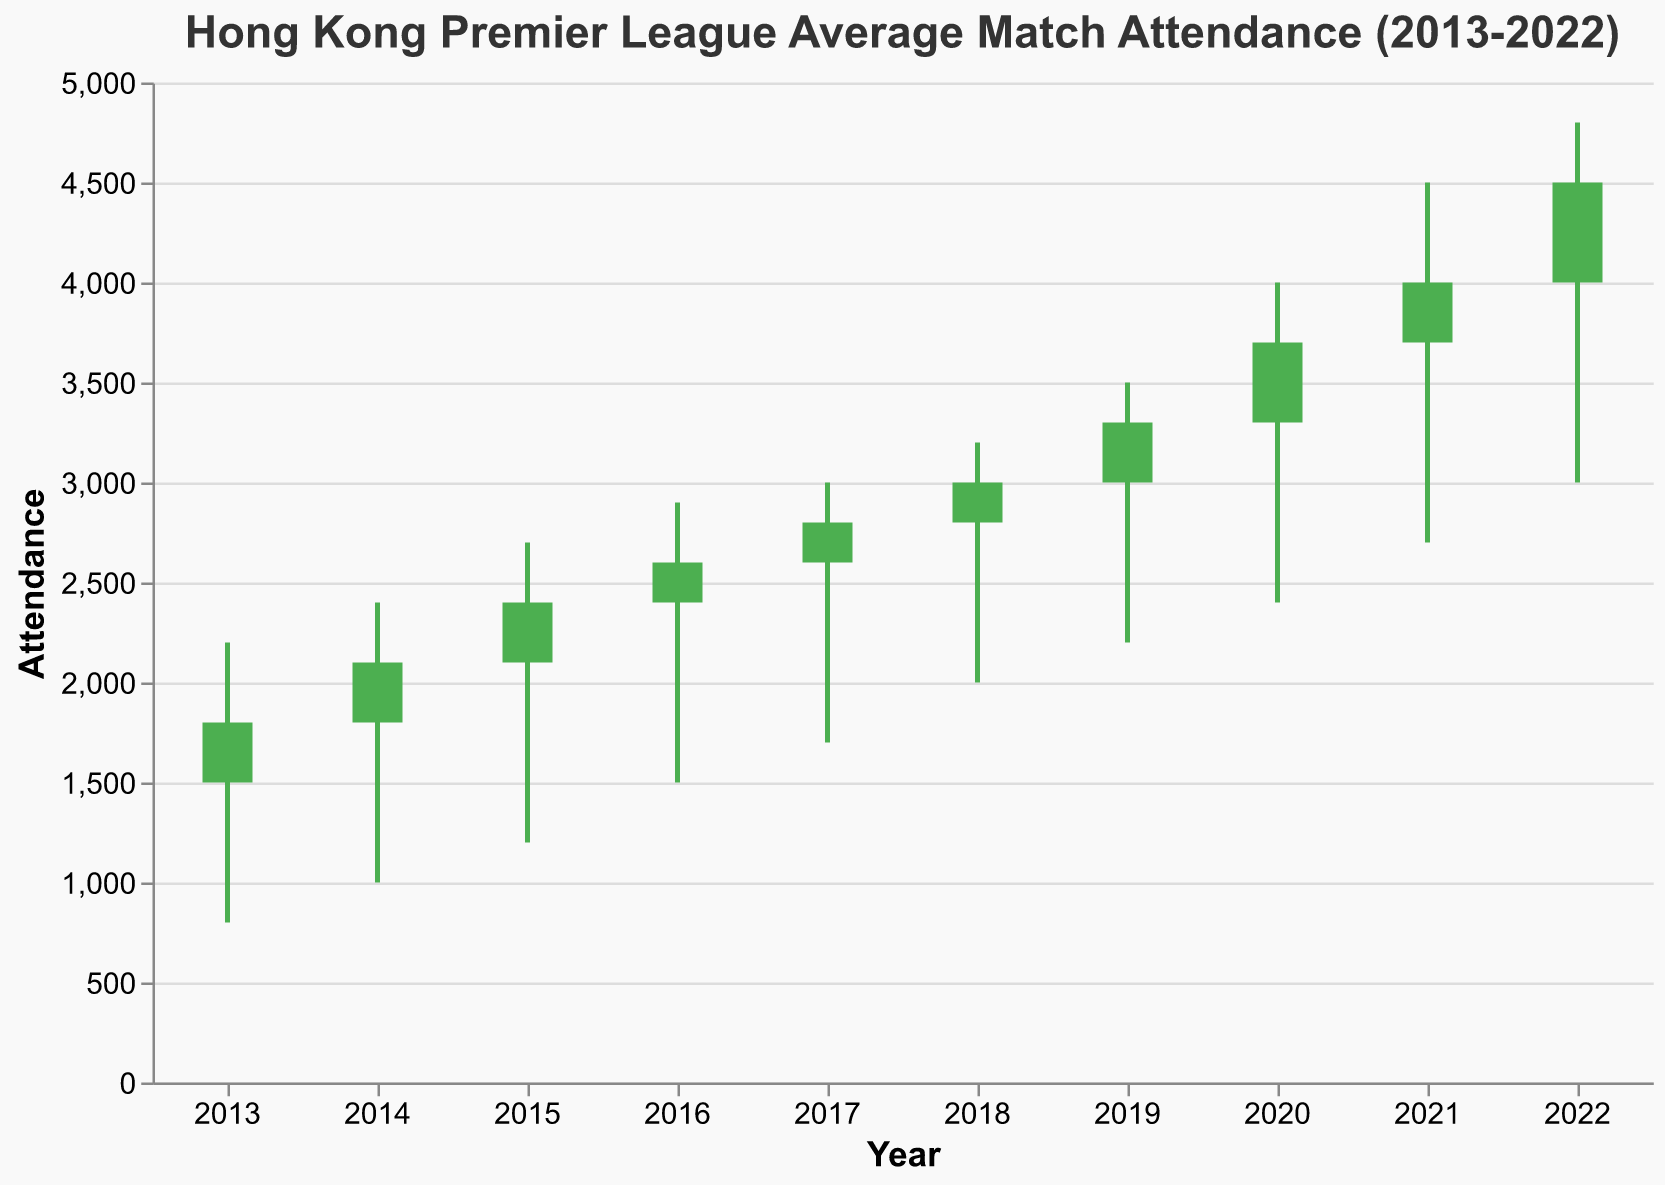What's the title of the figure? The title of the figure is displayed prominently at the top and reads "Hong Kong Premier League Average Match Attendance (2013-2022)."
Answer: Hong Kong Premier League Average Match Attendance (2013-2022) What does the y-axis represent? The y-axis is labeled "Attendance," which indicates that it represents the number of people who attended the matches.
Answer: Attendance In which year did the average match attendance have the highest high value? The highest high value is seen in the year 2022, where the peak attendance was 4800.
Answer: 2022 Which year had the lowest attendance recorded? The year with the lowest recorded attendance is 2013, with a low value of 800.
Answer: 2013 Was there any year where the match attendance decreased compared to the previous year, and if so, which year(s)? By comparing the open and close values, we can see that in every year from 2013 to 2022, the close is higher than or equal to the open, indicating that there was no year where the attendance decreased.
Answer: No such year What color represents years where the close attendance is higher than the open attendance? Years where the close attendance is higher than the open attendance are represented in green.
Answer: Green Between 2017 and 2020, how much did the highest match attendance increase by? The highest attendance in 2017 was 3000, and in 2020 it was 4000. The increase is calculated as 4000 - 3000.
Answer: 1000 Which year had the smallest difference between the high and low attendance? To determine this, subtract the low value from the high value for each year. For 2017, the difference is smallest, calculated as 3000 - 1700 = 1300.
Answer: 2017 What’s the average of the closing attendance values from 2018 to 2022? Sum the closing values from 2018 to 2022: 3000 + 3300 + 3700 + 4000 + 4500 = 18500. Divide by 5 for the average: 18500 / 5 = 3700.
Answer: 3700 How did the attendance trend change from the year 2016 to 2018? Looking at the opening values, the attendance increased from 2400 in 2016 to 2800 in 2018. Also, the closing values increased from 2600 in 2016 to 3000 in 2018. Thus, there was a continued upward trend in attendance.
Answer: Upward trend 